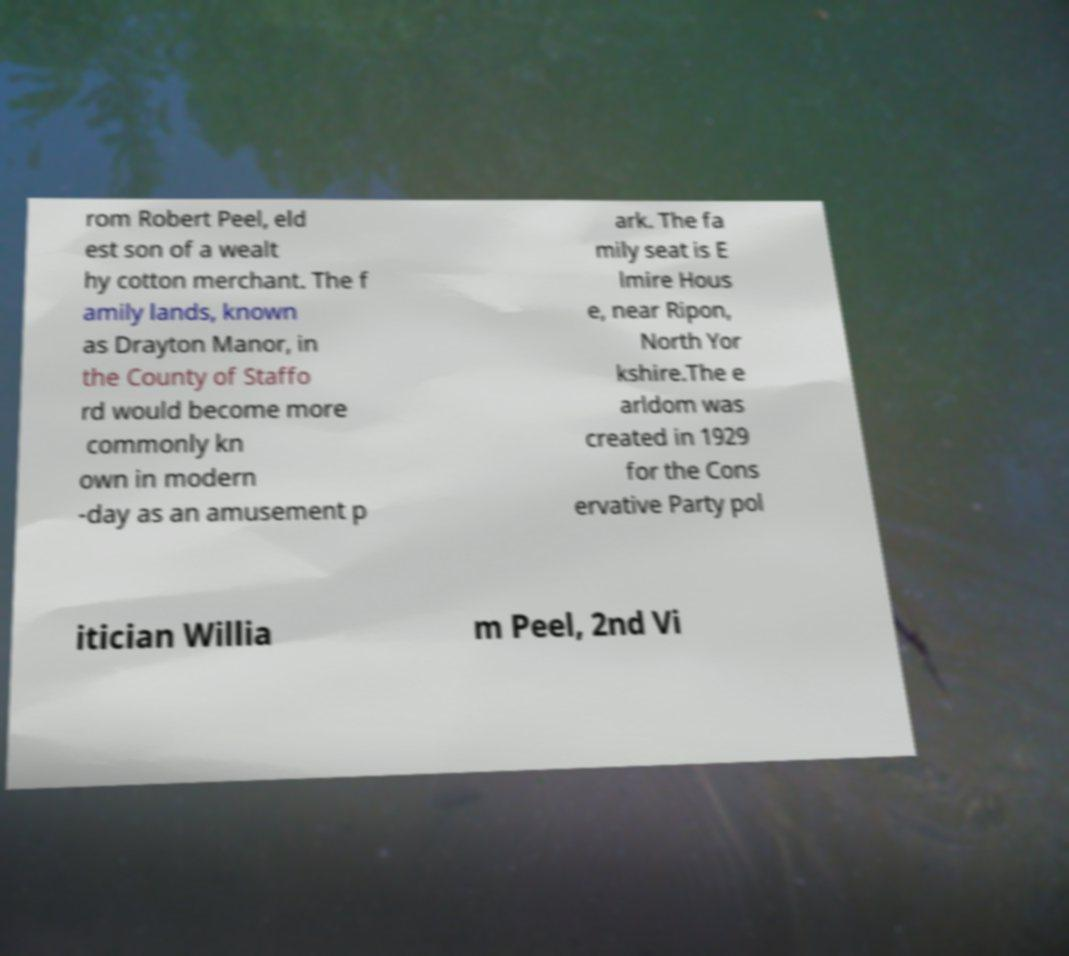Please read and relay the text visible in this image. What does it say? rom Robert Peel, eld est son of a wealt hy cotton merchant. The f amily lands, known as Drayton Manor, in the County of Staffo rd would become more commonly kn own in modern -day as an amusement p ark. The fa mily seat is E lmire Hous e, near Ripon, North Yor kshire.The e arldom was created in 1929 for the Cons ervative Party pol itician Willia m Peel, 2nd Vi 